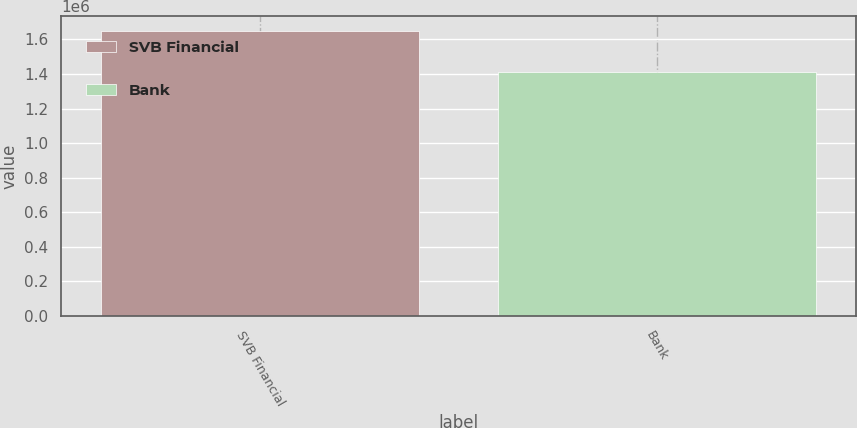<chart> <loc_0><loc_0><loc_500><loc_500><bar_chart><fcel>SVB Financial<fcel>Bank<nl><fcel>1.65154e+06<fcel>1.41414e+06<nl></chart> 